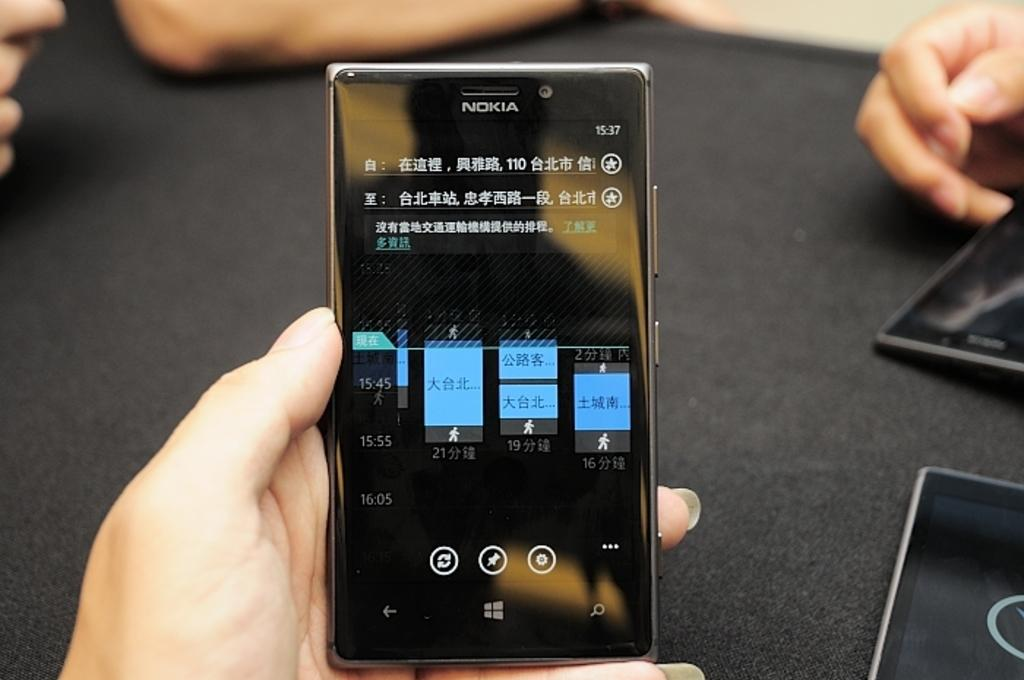<image>
Give a short and clear explanation of the subsequent image. A hand is holding a phone with graphs indicating the gains and losses of a Chinese company. 